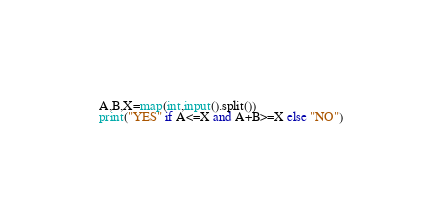<code> <loc_0><loc_0><loc_500><loc_500><_Python_>A,B,X=map(int,input().split())
print("YES" if A<=X and A+B>=X else "NO")</code> 